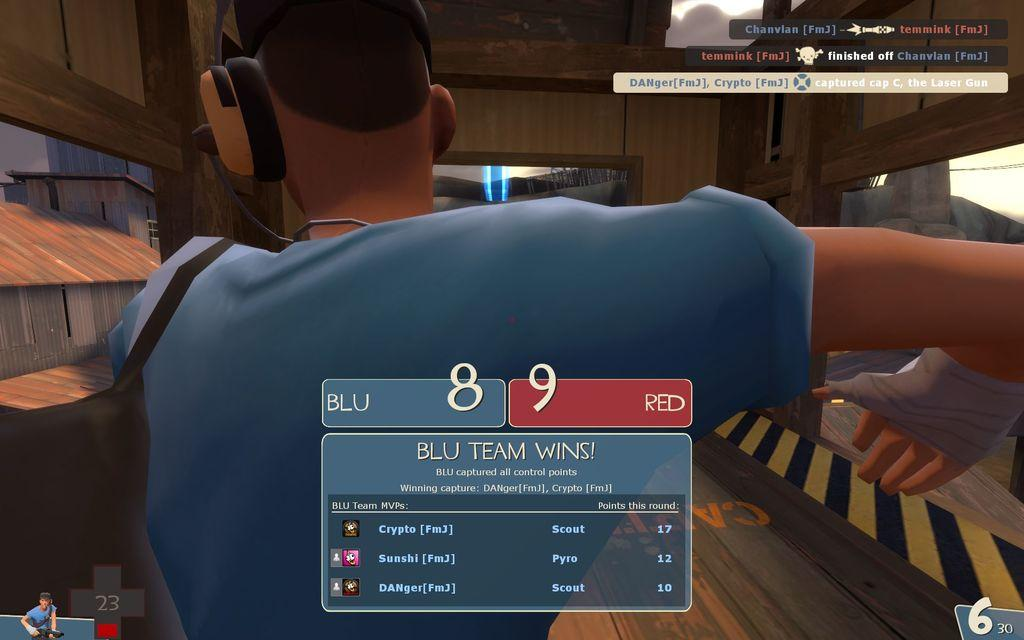What type of character is present in the image? There is an animated person in the image. What else is present in the image besides the animated person? There is animated text and logos in the image. What type of structures can be seen in the image? There are buildings in the image. What type of advice does the dad give to the rat in the image? There is no dad or rat present in the image; it only features an animated person, animated text, logos, and buildings. 